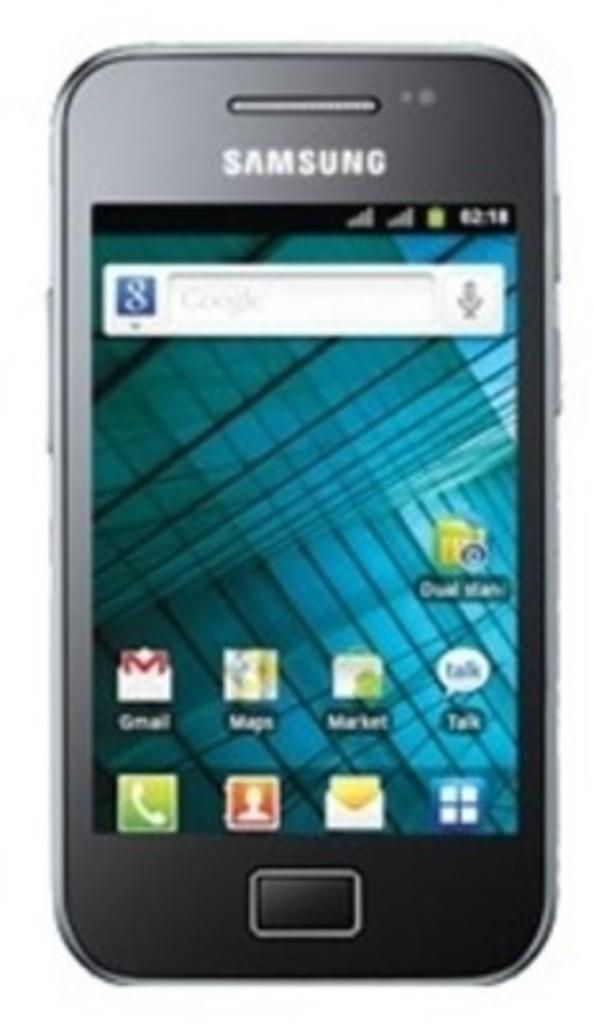Provide a one-sentence caption for the provided image. A Samsung smartphone in black on a main page. 